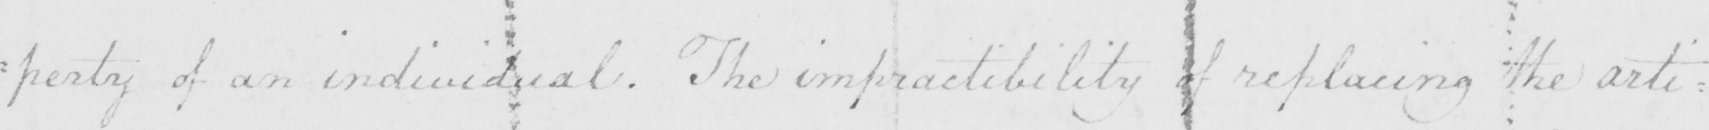Please provide the text content of this handwritten line. : perty of an individual . The impractibility of replacing the arti= 